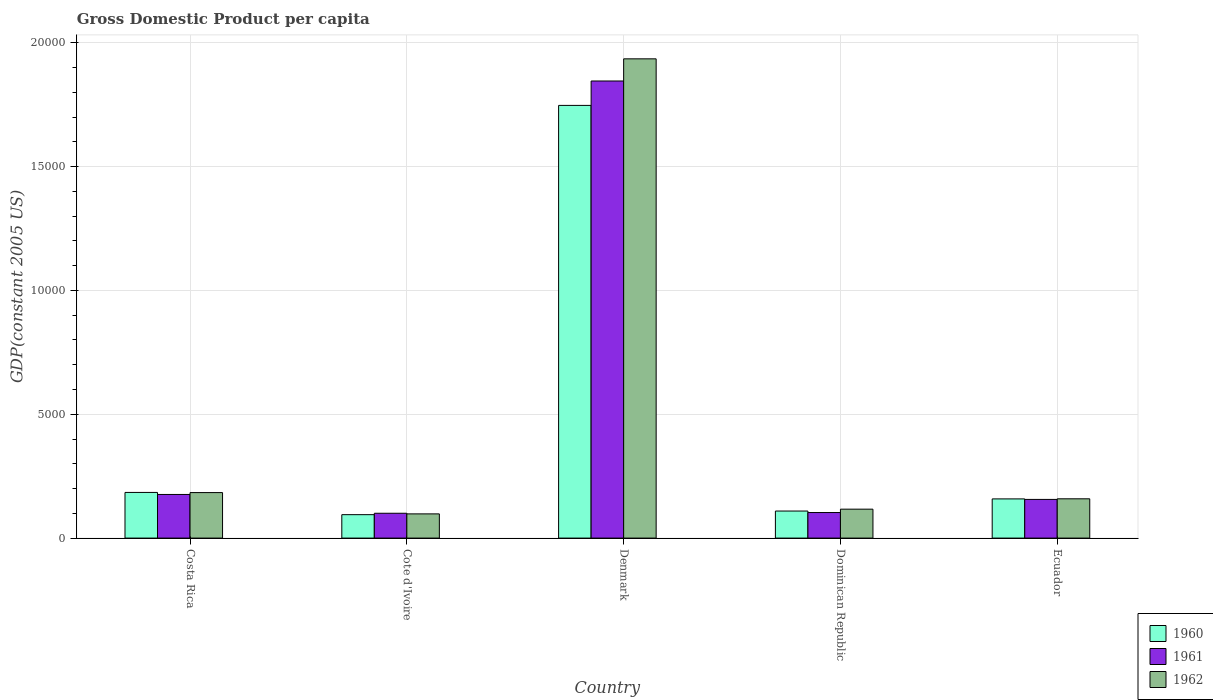How many different coloured bars are there?
Offer a terse response. 3. How many groups of bars are there?
Offer a very short reply. 5. What is the label of the 4th group of bars from the left?
Keep it short and to the point. Dominican Republic. In how many cases, is the number of bars for a given country not equal to the number of legend labels?
Make the answer very short. 0. What is the GDP per capita in 1961 in Cote d'Ivoire?
Make the answer very short. 1002.94. Across all countries, what is the maximum GDP per capita in 1961?
Make the answer very short. 1.85e+04. Across all countries, what is the minimum GDP per capita in 1961?
Keep it short and to the point. 1002.94. In which country was the GDP per capita in 1960 maximum?
Give a very brief answer. Denmark. In which country was the GDP per capita in 1960 minimum?
Your answer should be compact. Cote d'Ivoire. What is the total GDP per capita in 1960 in the graph?
Keep it short and to the point. 2.29e+04. What is the difference between the GDP per capita in 1962 in Costa Rica and that in Dominican Republic?
Provide a short and direct response. 669.5. What is the difference between the GDP per capita in 1961 in Ecuador and the GDP per capita in 1960 in Costa Rica?
Offer a terse response. -282.16. What is the average GDP per capita in 1962 per country?
Provide a short and direct response. 4984.51. What is the difference between the GDP per capita of/in 1962 and GDP per capita of/in 1960 in Denmark?
Give a very brief answer. 1879.94. In how many countries, is the GDP per capita in 1961 greater than 6000 US$?
Provide a short and direct response. 1. What is the ratio of the GDP per capita in 1962 in Denmark to that in Ecuador?
Provide a short and direct response. 12.2. Is the GDP per capita in 1961 in Costa Rica less than that in Cote d'Ivoire?
Your answer should be compact. No. Is the difference between the GDP per capita in 1962 in Costa Rica and Cote d'Ivoire greater than the difference between the GDP per capita in 1960 in Costa Rica and Cote d'Ivoire?
Offer a very short reply. No. What is the difference between the highest and the second highest GDP per capita in 1960?
Ensure brevity in your answer.  1.56e+04. What is the difference between the highest and the lowest GDP per capita in 1961?
Make the answer very short. 1.75e+04. In how many countries, is the GDP per capita in 1962 greater than the average GDP per capita in 1962 taken over all countries?
Provide a succinct answer. 1. Is the sum of the GDP per capita in 1960 in Denmark and Dominican Republic greater than the maximum GDP per capita in 1962 across all countries?
Keep it short and to the point. No. What does the 2nd bar from the left in Ecuador represents?
Give a very brief answer. 1961. What does the 1st bar from the right in Denmark represents?
Provide a succinct answer. 1962. Is it the case that in every country, the sum of the GDP per capita in 1960 and GDP per capita in 1962 is greater than the GDP per capita in 1961?
Give a very brief answer. Yes. How many bars are there?
Keep it short and to the point. 15. Does the graph contain any zero values?
Provide a succinct answer. No. Where does the legend appear in the graph?
Provide a short and direct response. Bottom right. How many legend labels are there?
Make the answer very short. 3. How are the legend labels stacked?
Provide a short and direct response. Vertical. What is the title of the graph?
Make the answer very short. Gross Domestic Product per capita. What is the label or title of the Y-axis?
Your response must be concise. GDP(constant 2005 US). What is the GDP(constant 2005 US) in 1960 in Costa Rica?
Ensure brevity in your answer.  1843.78. What is the GDP(constant 2005 US) in 1961 in Costa Rica?
Your response must be concise. 1761.56. What is the GDP(constant 2005 US) of 1962 in Costa Rica?
Offer a very short reply. 1837.73. What is the GDP(constant 2005 US) in 1960 in Cote d'Ivoire?
Ensure brevity in your answer.  945.76. What is the GDP(constant 2005 US) of 1961 in Cote d'Ivoire?
Provide a succinct answer. 1002.94. What is the GDP(constant 2005 US) of 1962 in Cote d'Ivoire?
Ensure brevity in your answer.  977.67. What is the GDP(constant 2005 US) of 1960 in Denmark?
Your response must be concise. 1.75e+04. What is the GDP(constant 2005 US) of 1961 in Denmark?
Your answer should be compact. 1.85e+04. What is the GDP(constant 2005 US) of 1962 in Denmark?
Keep it short and to the point. 1.94e+04. What is the GDP(constant 2005 US) in 1960 in Dominican Republic?
Your response must be concise. 1092.2. What is the GDP(constant 2005 US) of 1961 in Dominican Republic?
Give a very brief answer. 1031.78. What is the GDP(constant 2005 US) in 1962 in Dominican Republic?
Provide a succinct answer. 1168.23. What is the GDP(constant 2005 US) in 1960 in Ecuador?
Offer a terse response. 1582.31. What is the GDP(constant 2005 US) of 1961 in Ecuador?
Give a very brief answer. 1561.61. What is the GDP(constant 2005 US) of 1962 in Ecuador?
Your answer should be compact. 1586.66. Across all countries, what is the maximum GDP(constant 2005 US) of 1960?
Your answer should be very brief. 1.75e+04. Across all countries, what is the maximum GDP(constant 2005 US) of 1961?
Offer a terse response. 1.85e+04. Across all countries, what is the maximum GDP(constant 2005 US) of 1962?
Ensure brevity in your answer.  1.94e+04. Across all countries, what is the minimum GDP(constant 2005 US) of 1960?
Offer a terse response. 945.76. Across all countries, what is the minimum GDP(constant 2005 US) in 1961?
Offer a terse response. 1002.94. Across all countries, what is the minimum GDP(constant 2005 US) of 1962?
Provide a short and direct response. 977.67. What is the total GDP(constant 2005 US) of 1960 in the graph?
Offer a very short reply. 2.29e+04. What is the total GDP(constant 2005 US) in 1961 in the graph?
Offer a very short reply. 2.38e+04. What is the total GDP(constant 2005 US) of 1962 in the graph?
Provide a short and direct response. 2.49e+04. What is the difference between the GDP(constant 2005 US) in 1960 in Costa Rica and that in Cote d'Ivoire?
Your response must be concise. 898.02. What is the difference between the GDP(constant 2005 US) of 1961 in Costa Rica and that in Cote d'Ivoire?
Give a very brief answer. 758.62. What is the difference between the GDP(constant 2005 US) of 1962 in Costa Rica and that in Cote d'Ivoire?
Provide a short and direct response. 860.05. What is the difference between the GDP(constant 2005 US) of 1960 in Costa Rica and that in Denmark?
Your response must be concise. -1.56e+04. What is the difference between the GDP(constant 2005 US) of 1961 in Costa Rica and that in Denmark?
Your response must be concise. -1.67e+04. What is the difference between the GDP(constant 2005 US) of 1962 in Costa Rica and that in Denmark?
Offer a terse response. -1.75e+04. What is the difference between the GDP(constant 2005 US) in 1960 in Costa Rica and that in Dominican Republic?
Provide a short and direct response. 751.58. What is the difference between the GDP(constant 2005 US) of 1961 in Costa Rica and that in Dominican Republic?
Your response must be concise. 729.79. What is the difference between the GDP(constant 2005 US) in 1962 in Costa Rica and that in Dominican Republic?
Offer a very short reply. 669.5. What is the difference between the GDP(constant 2005 US) of 1960 in Costa Rica and that in Ecuador?
Ensure brevity in your answer.  261.47. What is the difference between the GDP(constant 2005 US) in 1961 in Costa Rica and that in Ecuador?
Keep it short and to the point. 199.95. What is the difference between the GDP(constant 2005 US) in 1962 in Costa Rica and that in Ecuador?
Provide a succinct answer. 251.07. What is the difference between the GDP(constant 2005 US) of 1960 in Cote d'Ivoire and that in Denmark?
Provide a short and direct response. -1.65e+04. What is the difference between the GDP(constant 2005 US) in 1961 in Cote d'Ivoire and that in Denmark?
Offer a terse response. -1.75e+04. What is the difference between the GDP(constant 2005 US) of 1962 in Cote d'Ivoire and that in Denmark?
Ensure brevity in your answer.  -1.84e+04. What is the difference between the GDP(constant 2005 US) in 1960 in Cote d'Ivoire and that in Dominican Republic?
Offer a very short reply. -146.44. What is the difference between the GDP(constant 2005 US) of 1961 in Cote d'Ivoire and that in Dominican Republic?
Offer a very short reply. -28.84. What is the difference between the GDP(constant 2005 US) of 1962 in Cote d'Ivoire and that in Dominican Republic?
Offer a very short reply. -190.56. What is the difference between the GDP(constant 2005 US) in 1960 in Cote d'Ivoire and that in Ecuador?
Offer a very short reply. -636.55. What is the difference between the GDP(constant 2005 US) in 1961 in Cote d'Ivoire and that in Ecuador?
Your response must be concise. -558.67. What is the difference between the GDP(constant 2005 US) of 1962 in Cote d'Ivoire and that in Ecuador?
Offer a terse response. -608.98. What is the difference between the GDP(constant 2005 US) in 1960 in Denmark and that in Dominican Republic?
Provide a short and direct response. 1.64e+04. What is the difference between the GDP(constant 2005 US) of 1961 in Denmark and that in Dominican Republic?
Offer a terse response. 1.74e+04. What is the difference between the GDP(constant 2005 US) in 1962 in Denmark and that in Dominican Republic?
Your response must be concise. 1.82e+04. What is the difference between the GDP(constant 2005 US) of 1960 in Denmark and that in Ecuador?
Provide a succinct answer. 1.59e+04. What is the difference between the GDP(constant 2005 US) of 1961 in Denmark and that in Ecuador?
Give a very brief answer. 1.69e+04. What is the difference between the GDP(constant 2005 US) in 1962 in Denmark and that in Ecuador?
Your answer should be compact. 1.78e+04. What is the difference between the GDP(constant 2005 US) of 1960 in Dominican Republic and that in Ecuador?
Your response must be concise. -490.11. What is the difference between the GDP(constant 2005 US) in 1961 in Dominican Republic and that in Ecuador?
Your answer should be compact. -529.84. What is the difference between the GDP(constant 2005 US) in 1962 in Dominican Republic and that in Ecuador?
Offer a terse response. -418.42. What is the difference between the GDP(constant 2005 US) in 1960 in Costa Rica and the GDP(constant 2005 US) in 1961 in Cote d'Ivoire?
Your answer should be very brief. 840.84. What is the difference between the GDP(constant 2005 US) of 1960 in Costa Rica and the GDP(constant 2005 US) of 1962 in Cote d'Ivoire?
Make the answer very short. 866.11. What is the difference between the GDP(constant 2005 US) in 1961 in Costa Rica and the GDP(constant 2005 US) in 1962 in Cote d'Ivoire?
Make the answer very short. 783.89. What is the difference between the GDP(constant 2005 US) of 1960 in Costa Rica and the GDP(constant 2005 US) of 1961 in Denmark?
Your response must be concise. -1.66e+04. What is the difference between the GDP(constant 2005 US) in 1960 in Costa Rica and the GDP(constant 2005 US) in 1962 in Denmark?
Your answer should be compact. -1.75e+04. What is the difference between the GDP(constant 2005 US) of 1961 in Costa Rica and the GDP(constant 2005 US) of 1962 in Denmark?
Your response must be concise. -1.76e+04. What is the difference between the GDP(constant 2005 US) in 1960 in Costa Rica and the GDP(constant 2005 US) in 1961 in Dominican Republic?
Provide a short and direct response. 812. What is the difference between the GDP(constant 2005 US) in 1960 in Costa Rica and the GDP(constant 2005 US) in 1962 in Dominican Republic?
Ensure brevity in your answer.  675.55. What is the difference between the GDP(constant 2005 US) in 1961 in Costa Rica and the GDP(constant 2005 US) in 1962 in Dominican Republic?
Offer a terse response. 593.33. What is the difference between the GDP(constant 2005 US) of 1960 in Costa Rica and the GDP(constant 2005 US) of 1961 in Ecuador?
Provide a short and direct response. 282.17. What is the difference between the GDP(constant 2005 US) of 1960 in Costa Rica and the GDP(constant 2005 US) of 1962 in Ecuador?
Your answer should be compact. 257.12. What is the difference between the GDP(constant 2005 US) of 1961 in Costa Rica and the GDP(constant 2005 US) of 1962 in Ecuador?
Ensure brevity in your answer.  174.91. What is the difference between the GDP(constant 2005 US) of 1960 in Cote d'Ivoire and the GDP(constant 2005 US) of 1961 in Denmark?
Make the answer very short. -1.75e+04. What is the difference between the GDP(constant 2005 US) of 1960 in Cote d'Ivoire and the GDP(constant 2005 US) of 1962 in Denmark?
Offer a very short reply. -1.84e+04. What is the difference between the GDP(constant 2005 US) of 1961 in Cote d'Ivoire and the GDP(constant 2005 US) of 1962 in Denmark?
Your response must be concise. -1.83e+04. What is the difference between the GDP(constant 2005 US) in 1960 in Cote d'Ivoire and the GDP(constant 2005 US) in 1961 in Dominican Republic?
Offer a very short reply. -86.02. What is the difference between the GDP(constant 2005 US) of 1960 in Cote d'Ivoire and the GDP(constant 2005 US) of 1962 in Dominican Republic?
Your answer should be compact. -222.47. What is the difference between the GDP(constant 2005 US) in 1961 in Cote d'Ivoire and the GDP(constant 2005 US) in 1962 in Dominican Republic?
Give a very brief answer. -165.29. What is the difference between the GDP(constant 2005 US) of 1960 in Cote d'Ivoire and the GDP(constant 2005 US) of 1961 in Ecuador?
Provide a succinct answer. -615.85. What is the difference between the GDP(constant 2005 US) in 1960 in Cote d'Ivoire and the GDP(constant 2005 US) in 1962 in Ecuador?
Your response must be concise. -640.9. What is the difference between the GDP(constant 2005 US) in 1961 in Cote d'Ivoire and the GDP(constant 2005 US) in 1962 in Ecuador?
Offer a very short reply. -583.72. What is the difference between the GDP(constant 2005 US) in 1960 in Denmark and the GDP(constant 2005 US) in 1961 in Dominican Republic?
Offer a terse response. 1.64e+04. What is the difference between the GDP(constant 2005 US) in 1960 in Denmark and the GDP(constant 2005 US) in 1962 in Dominican Republic?
Give a very brief answer. 1.63e+04. What is the difference between the GDP(constant 2005 US) in 1961 in Denmark and the GDP(constant 2005 US) in 1962 in Dominican Republic?
Provide a succinct answer. 1.73e+04. What is the difference between the GDP(constant 2005 US) in 1960 in Denmark and the GDP(constant 2005 US) in 1961 in Ecuador?
Offer a very short reply. 1.59e+04. What is the difference between the GDP(constant 2005 US) in 1960 in Denmark and the GDP(constant 2005 US) in 1962 in Ecuador?
Offer a very short reply. 1.59e+04. What is the difference between the GDP(constant 2005 US) of 1961 in Denmark and the GDP(constant 2005 US) of 1962 in Ecuador?
Offer a terse response. 1.69e+04. What is the difference between the GDP(constant 2005 US) of 1960 in Dominican Republic and the GDP(constant 2005 US) of 1961 in Ecuador?
Provide a succinct answer. -469.41. What is the difference between the GDP(constant 2005 US) of 1960 in Dominican Republic and the GDP(constant 2005 US) of 1962 in Ecuador?
Make the answer very short. -494.45. What is the difference between the GDP(constant 2005 US) in 1961 in Dominican Republic and the GDP(constant 2005 US) in 1962 in Ecuador?
Offer a very short reply. -554.88. What is the average GDP(constant 2005 US) of 1960 per country?
Provide a succinct answer. 4587.28. What is the average GDP(constant 2005 US) of 1961 per country?
Provide a succinct answer. 4763.09. What is the average GDP(constant 2005 US) of 1962 per country?
Make the answer very short. 4984.51. What is the difference between the GDP(constant 2005 US) of 1960 and GDP(constant 2005 US) of 1961 in Costa Rica?
Ensure brevity in your answer.  82.22. What is the difference between the GDP(constant 2005 US) in 1960 and GDP(constant 2005 US) in 1962 in Costa Rica?
Your answer should be compact. 6.05. What is the difference between the GDP(constant 2005 US) in 1961 and GDP(constant 2005 US) in 1962 in Costa Rica?
Provide a short and direct response. -76.16. What is the difference between the GDP(constant 2005 US) of 1960 and GDP(constant 2005 US) of 1961 in Cote d'Ivoire?
Your answer should be compact. -57.18. What is the difference between the GDP(constant 2005 US) in 1960 and GDP(constant 2005 US) in 1962 in Cote d'Ivoire?
Your answer should be very brief. -31.91. What is the difference between the GDP(constant 2005 US) of 1961 and GDP(constant 2005 US) of 1962 in Cote d'Ivoire?
Offer a very short reply. 25.27. What is the difference between the GDP(constant 2005 US) in 1960 and GDP(constant 2005 US) in 1961 in Denmark?
Provide a succinct answer. -985.22. What is the difference between the GDP(constant 2005 US) of 1960 and GDP(constant 2005 US) of 1962 in Denmark?
Offer a terse response. -1879.94. What is the difference between the GDP(constant 2005 US) of 1961 and GDP(constant 2005 US) of 1962 in Denmark?
Make the answer very short. -894.72. What is the difference between the GDP(constant 2005 US) of 1960 and GDP(constant 2005 US) of 1961 in Dominican Republic?
Your answer should be very brief. 60.43. What is the difference between the GDP(constant 2005 US) of 1960 and GDP(constant 2005 US) of 1962 in Dominican Republic?
Your response must be concise. -76.03. What is the difference between the GDP(constant 2005 US) of 1961 and GDP(constant 2005 US) of 1962 in Dominican Republic?
Make the answer very short. -136.46. What is the difference between the GDP(constant 2005 US) in 1960 and GDP(constant 2005 US) in 1961 in Ecuador?
Your answer should be very brief. 20.7. What is the difference between the GDP(constant 2005 US) in 1960 and GDP(constant 2005 US) in 1962 in Ecuador?
Your response must be concise. -4.35. What is the difference between the GDP(constant 2005 US) of 1961 and GDP(constant 2005 US) of 1962 in Ecuador?
Give a very brief answer. -25.04. What is the ratio of the GDP(constant 2005 US) in 1960 in Costa Rica to that in Cote d'Ivoire?
Your answer should be very brief. 1.95. What is the ratio of the GDP(constant 2005 US) in 1961 in Costa Rica to that in Cote d'Ivoire?
Make the answer very short. 1.76. What is the ratio of the GDP(constant 2005 US) of 1962 in Costa Rica to that in Cote d'Ivoire?
Provide a succinct answer. 1.88. What is the ratio of the GDP(constant 2005 US) in 1960 in Costa Rica to that in Denmark?
Provide a succinct answer. 0.11. What is the ratio of the GDP(constant 2005 US) in 1961 in Costa Rica to that in Denmark?
Make the answer very short. 0.1. What is the ratio of the GDP(constant 2005 US) in 1962 in Costa Rica to that in Denmark?
Keep it short and to the point. 0.1. What is the ratio of the GDP(constant 2005 US) in 1960 in Costa Rica to that in Dominican Republic?
Offer a very short reply. 1.69. What is the ratio of the GDP(constant 2005 US) in 1961 in Costa Rica to that in Dominican Republic?
Keep it short and to the point. 1.71. What is the ratio of the GDP(constant 2005 US) of 1962 in Costa Rica to that in Dominican Republic?
Provide a short and direct response. 1.57. What is the ratio of the GDP(constant 2005 US) of 1960 in Costa Rica to that in Ecuador?
Your response must be concise. 1.17. What is the ratio of the GDP(constant 2005 US) of 1961 in Costa Rica to that in Ecuador?
Your answer should be compact. 1.13. What is the ratio of the GDP(constant 2005 US) of 1962 in Costa Rica to that in Ecuador?
Keep it short and to the point. 1.16. What is the ratio of the GDP(constant 2005 US) in 1960 in Cote d'Ivoire to that in Denmark?
Offer a very short reply. 0.05. What is the ratio of the GDP(constant 2005 US) in 1961 in Cote d'Ivoire to that in Denmark?
Offer a very short reply. 0.05. What is the ratio of the GDP(constant 2005 US) of 1962 in Cote d'Ivoire to that in Denmark?
Offer a very short reply. 0.05. What is the ratio of the GDP(constant 2005 US) in 1960 in Cote d'Ivoire to that in Dominican Republic?
Keep it short and to the point. 0.87. What is the ratio of the GDP(constant 2005 US) of 1961 in Cote d'Ivoire to that in Dominican Republic?
Your response must be concise. 0.97. What is the ratio of the GDP(constant 2005 US) of 1962 in Cote d'Ivoire to that in Dominican Republic?
Provide a short and direct response. 0.84. What is the ratio of the GDP(constant 2005 US) in 1960 in Cote d'Ivoire to that in Ecuador?
Make the answer very short. 0.6. What is the ratio of the GDP(constant 2005 US) of 1961 in Cote d'Ivoire to that in Ecuador?
Your answer should be compact. 0.64. What is the ratio of the GDP(constant 2005 US) of 1962 in Cote d'Ivoire to that in Ecuador?
Your response must be concise. 0.62. What is the ratio of the GDP(constant 2005 US) of 1960 in Denmark to that in Dominican Republic?
Provide a short and direct response. 16. What is the ratio of the GDP(constant 2005 US) in 1961 in Denmark to that in Dominican Republic?
Your response must be concise. 17.89. What is the ratio of the GDP(constant 2005 US) in 1962 in Denmark to that in Dominican Republic?
Ensure brevity in your answer.  16.57. What is the ratio of the GDP(constant 2005 US) in 1960 in Denmark to that in Ecuador?
Your answer should be very brief. 11.04. What is the ratio of the GDP(constant 2005 US) of 1961 in Denmark to that in Ecuador?
Your answer should be very brief. 11.82. What is the ratio of the GDP(constant 2005 US) in 1962 in Denmark to that in Ecuador?
Your answer should be very brief. 12.2. What is the ratio of the GDP(constant 2005 US) in 1960 in Dominican Republic to that in Ecuador?
Make the answer very short. 0.69. What is the ratio of the GDP(constant 2005 US) in 1961 in Dominican Republic to that in Ecuador?
Provide a succinct answer. 0.66. What is the ratio of the GDP(constant 2005 US) of 1962 in Dominican Republic to that in Ecuador?
Offer a very short reply. 0.74. What is the difference between the highest and the second highest GDP(constant 2005 US) of 1960?
Ensure brevity in your answer.  1.56e+04. What is the difference between the highest and the second highest GDP(constant 2005 US) in 1961?
Your answer should be compact. 1.67e+04. What is the difference between the highest and the second highest GDP(constant 2005 US) of 1962?
Provide a short and direct response. 1.75e+04. What is the difference between the highest and the lowest GDP(constant 2005 US) in 1960?
Your answer should be very brief. 1.65e+04. What is the difference between the highest and the lowest GDP(constant 2005 US) of 1961?
Your response must be concise. 1.75e+04. What is the difference between the highest and the lowest GDP(constant 2005 US) of 1962?
Provide a short and direct response. 1.84e+04. 